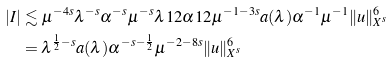<formula> <loc_0><loc_0><loc_500><loc_500>| I | & \lesssim \mu ^ { - 4 s } \lambda ^ { - s } \alpha ^ { - s } \mu ^ { - s } \lambda ^ { } { 1 } 2 \alpha ^ { } { 1 } 2 \mu ^ { - 1 - 3 s } a ( \lambda ) \alpha ^ { - 1 } \mu ^ { - 1 } \| u \| _ { X ^ { s } } ^ { 6 } \\ & = \lambda ^ { \frac { 1 } { 2 } - s } a ( \lambda ) \alpha ^ { - s - \frac { 1 } { 2 } } \mu ^ { - 2 - 8 s } \| u \| _ { X ^ { s } } ^ { 6 }</formula> 